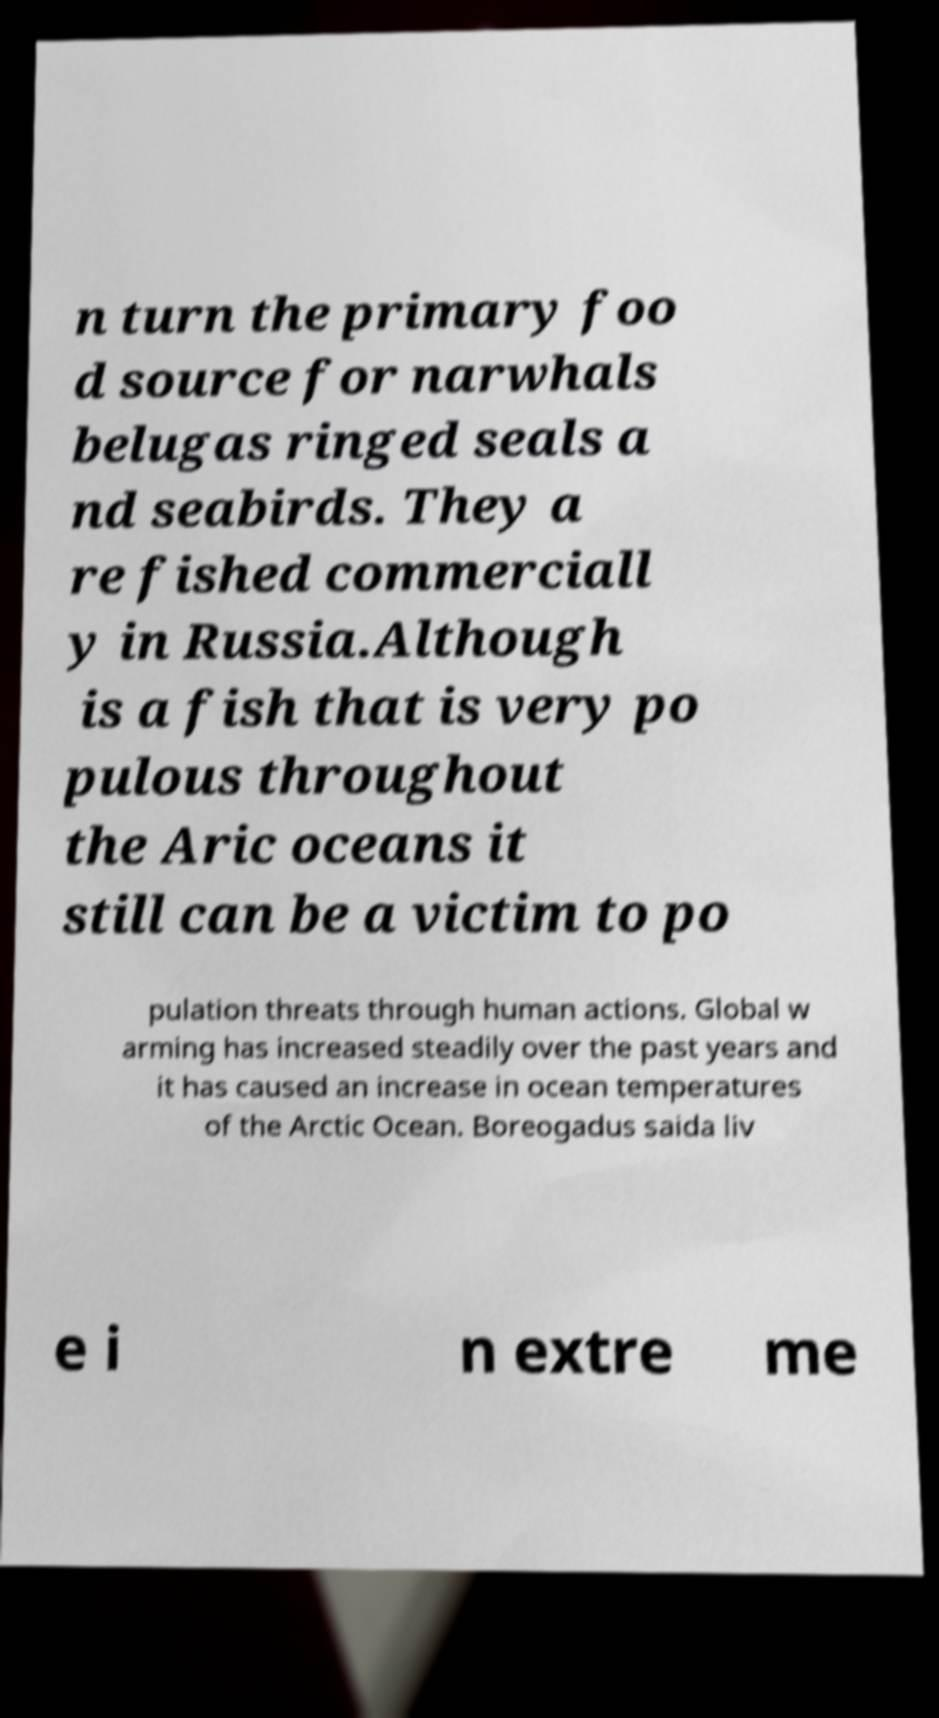There's text embedded in this image that I need extracted. Can you transcribe it verbatim? n turn the primary foo d source for narwhals belugas ringed seals a nd seabirds. They a re fished commerciall y in Russia.Although is a fish that is very po pulous throughout the Aric oceans it still can be a victim to po pulation threats through human actions. Global w arming has increased steadily over the past years and it has caused an increase in ocean temperatures of the Arctic Ocean. Boreogadus saida liv e i n extre me 